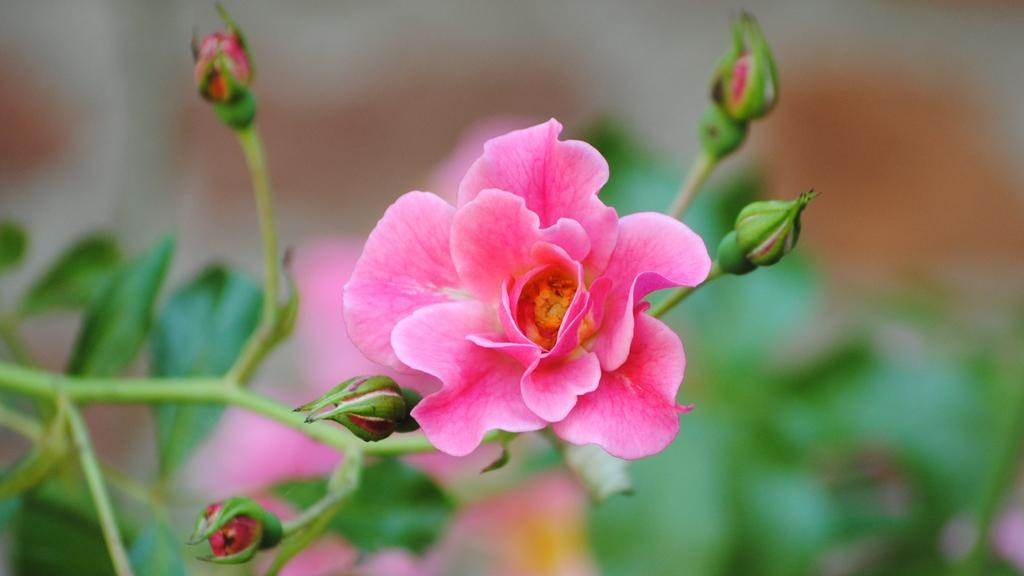What type of plant is visible in the image? There is a plant in the image, and it has flowers and buds. What stage of growth are the flowers in the image? The flowers are visible on the plant in the image. What can be seen in the background of the image? The background of the image is blurry. Can you tell me how many flies are sitting on the plant in the image? There are no flies present in the image; it only features a plant with flowers and buds. 